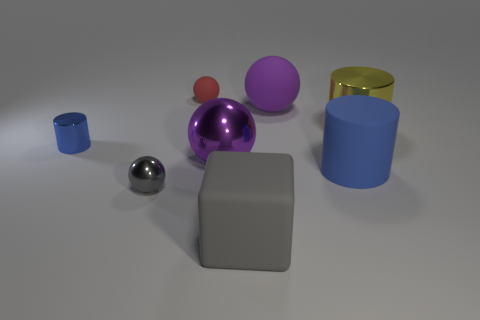What size is the matte object that is the same color as the small cylinder?
Provide a short and direct response. Large. How many purple things are in front of the metal cylinder to the right of the large purple rubber thing?
Provide a short and direct response. 1. Is there any other thing that has the same color as the big rubber ball?
Offer a very short reply. Yes. There is a red thing that is made of the same material as the large blue thing; what shape is it?
Provide a short and direct response. Sphere. Does the small cylinder have the same color as the tiny rubber sphere?
Your response must be concise. No. Are the tiny ball that is in front of the large blue object and the large purple thing behind the small cylinder made of the same material?
Keep it short and to the point. No. What number of objects are matte cubes or small things in front of the tiny red rubber ball?
Your response must be concise. 3. Is there anything else that is the same material as the big gray block?
Your answer should be compact. Yes. The tiny object that is the same color as the big block is what shape?
Offer a terse response. Sphere. What is the material of the big cube?
Offer a very short reply. Rubber. 